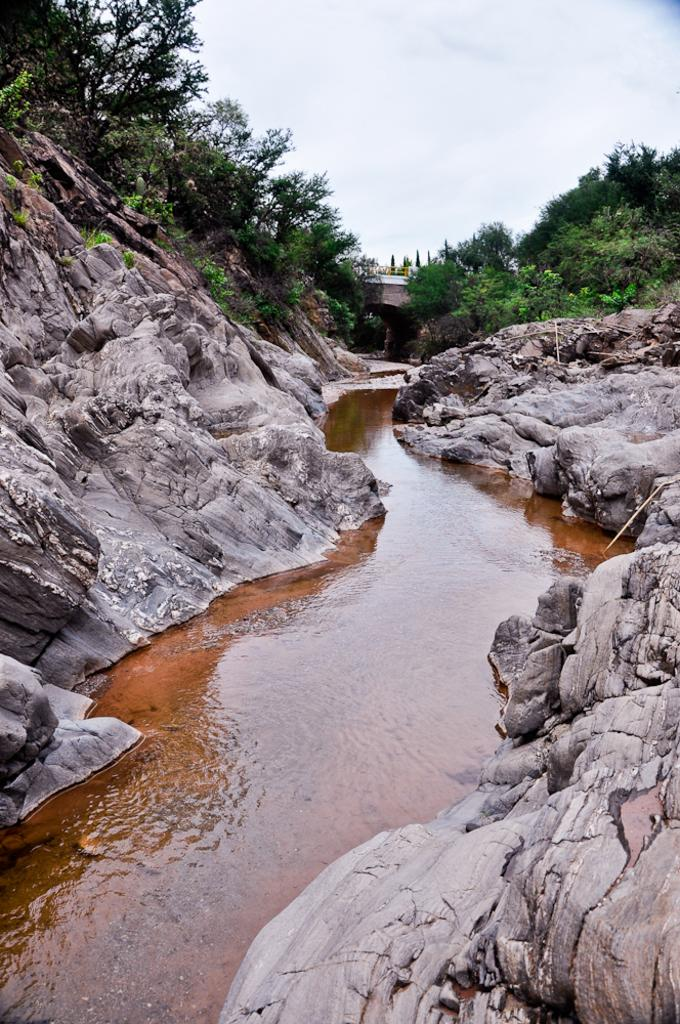What is the primary element visible in the image? There is water in the image. What other objects or features are near the water? There are rocks beside the water. What can be seen in the background of the image? There are many trees and a bridge in the background of the image. What is visible at the top of the image? The sky is visible at the top of the image. What type of furniture can be seen floating in the water in the image? There is no furniture visible in the image; it only features water, rocks, trees, a bridge, and the sky. 